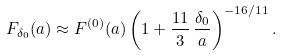Convert formula to latex. <formula><loc_0><loc_0><loc_500><loc_500>F _ { \delta _ { 0 } } ( a ) \approx F ^ { ( 0 ) } ( a ) \left ( 1 + \frac { 1 1 } { 3 } \, \frac { \delta _ { 0 } } { a } \right ) ^ { - 1 6 / 1 1 } .</formula> 